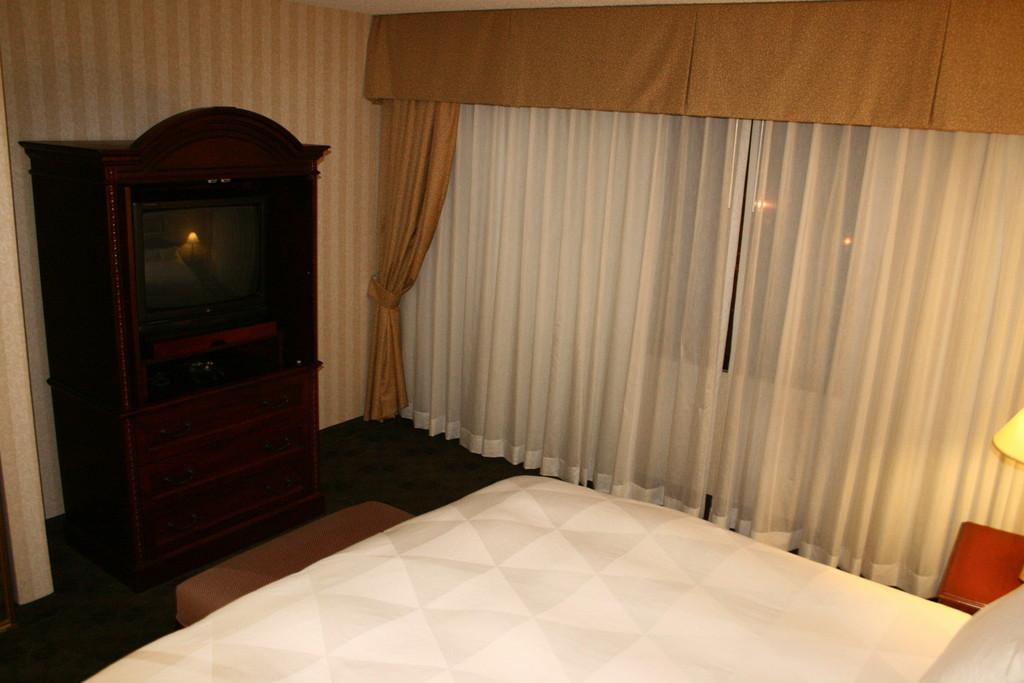What type of furniture is present in the image? There is a wooden drawer in the image. What electronic device can be seen in the image? There is a television in the image. What architectural feature is visible in the image? There is a wall in the image. What type of window is present in the image? There is a glass window in the image. What type of window treatment is present in the image? There are curtains in the image. What can be seen at the bottom of the image? There is a white texture at the bottom of the image. How many fangs can be seen on the television in the image? There are no fangs present on the television or any other object in the image. What type of birds can be seen flying through the glass window in the image? There are no birds visible in the image, and the glass window is not transparent enough to see through. 